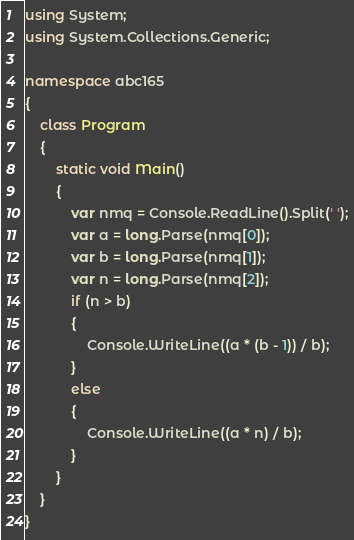Convert code to text. <code><loc_0><loc_0><loc_500><loc_500><_C#_>using System;
using System.Collections.Generic;

namespace abc165
{
    class Program
    {
        static void Main()
        {
            var nmq = Console.ReadLine().Split(' ');
            var a = long.Parse(nmq[0]);
            var b = long.Parse(nmq[1]);
            var n = long.Parse(nmq[2]);
            if (n > b)
            {
                Console.WriteLine((a * (b - 1)) / b);
            }
            else
            {
                Console.WriteLine((a * n) / b);
            }
        }
    }
}
</code> 